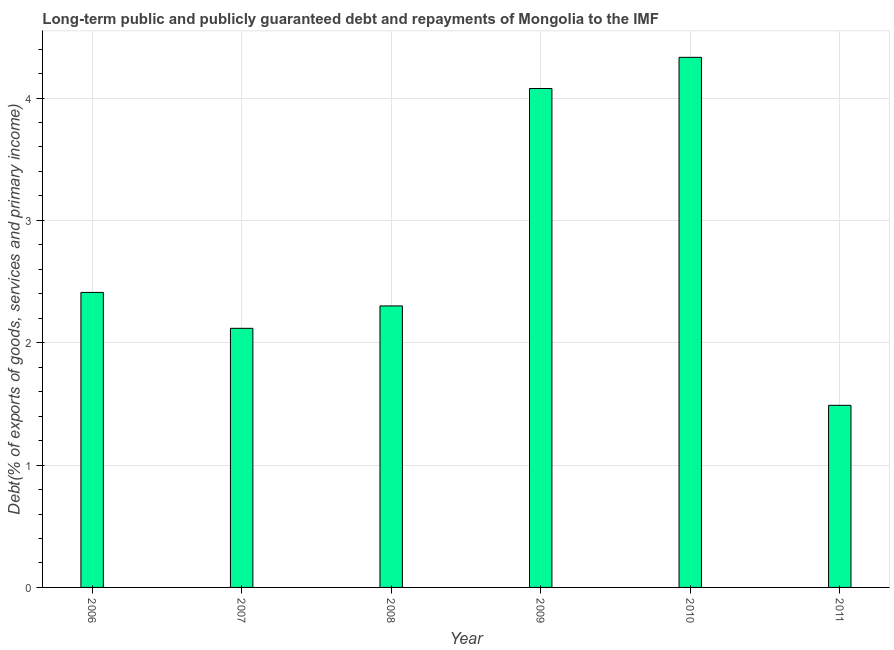Does the graph contain any zero values?
Your response must be concise. No. Does the graph contain grids?
Provide a short and direct response. Yes. What is the title of the graph?
Make the answer very short. Long-term public and publicly guaranteed debt and repayments of Mongolia to the IMF. What is the label or title of the Y-axis?
Provide a succinct answer. Debt(% of exports of goods, services and primary income). What is the debt service in 2011?
Your answer should be very brief. 1.49. Across all years, what is the maximum debt service?
Your response must be concise. 4.33. Across all years, what is the minimum debt service?
Your answer should be compact. 1.49. In which year was the debt service minimum?
Your answer should be very brief. 2011. What is the sum of the debt service?
Provide a short and direct response. 16.73. What is the difference between the debt service in 2009 and 2010?
Give a very brief answer. -0.26. What is the average debt service per year?
Give a very brief answer. 2.79. What is the median debt service?
Give a very brief answer. 2.36. Do a majority of the years between 2009 and 2007 (inclusive) have debt service greater than 3 %?
Your answer should be compact. Yes. What is the ratio of the debt service in 2006 to that in 2008?
Offer a terse response. 1.05. Is the difference between the debt service in 2007 and 2008 greater than the difference between any two years?
Your answer should be very brief. No. What is the difference between the highest and the second highest debt service?
Ensure brevity in your answer.  0.26. What is the difference between the highest and the lowest debt service?
Give a very brief answer. 2.84. Are all the bars in the graph horizontal?
Offer a terse response. No. What is the difference between two consecutive major ticks on the Y-axis?
Make the answer very short. 1. Are the values on the major ticks of Y-axis written in scientific E-notation?
Your answer should be very brief. No. What is the Debt(% of exports of goods, services and primary income) in 2006?
Your answer should be very brief. 2.41. What is the Debt(% of exports of goods, services and primary income) of 2007?
Your response must be concise. 2.12. What is the Debt(% of exports of goods, services and primary income) of 2008?
Offer a terse response. 2.3. What is the Debt(% of exports of goods, services and primary income) in 2009?
Keep it short and to the point. 4.08. What is the Debt(% of exports of goods, services and primary income) in 2010?
Your answer should be compact. 4.33. What is the Debt(% of exports of goods, services and primary income) of 2011?
Your response must be concise. 1.49. What is the difference between the Debt(% of exports of goods, services and primary income) in 2006 and 2007?
Ensure brevity in your answer.  0.29. What is the difference between the Debt(% of exports of goods, services and primary income) in 2006 and 2008?
Keep it short and to the point. 0.11. What is the difference between the Debt(% of exports of goods, services and primary income) in 2006 and 2009?
Ensure brevity in your answer.  -1.67. What is the difference between the Debt(% of exports of goods, services and primary income) in 2006 and 2010?
Offer a terse response. -1.92. What is the difference between the Debt(% of exports of goods, services and primary income) in 2006 and 2011?
Provide a short and direct response. 0.92. What is the difference between the Debt(% of exports of goods, services and primary income) in 2007 and 2008?
Provide a succinct answer. -0.18. What is the difference between the Debt(% of exports of goods, services and primary income) in 2007 and 2009?
Your answer should be compact. -1.96. What is the difference between the Debt(% of exports of goods, services and primary income) in 2007 and 2010?
Keep it short and to the point. -2.22. What is the difference between the Debt(% of exports of goods, services and primary income) in 2007 and 2011?
Your response must be concise. 0.63. What is the difference between the Debt(% of exports of goods, services and primary income) in 2008 and 2009?
Provide a succinct answer. -1.78. What is the difference between the Debt(% of exports of goods, services and primary income) in 2008 and 2010?
Offer a terse response. -2.03. What is the difference between the Debt(% of exports of goods, services and primary income) in 2008 and 2011?
Make the answer very short. 0.81. What is the difference between the Debt(% of exports of goods, services and primary income) in 2009 and 2010?
Give a very brief answer. -0.25. What is the difference between the Debt(% of exports of goods, services and primary income) in 2009 and 2011?
Keep it short and to the point. 2.59. What is the difference between the Debt(% of exports of goods, services and primary income) in 2010 and 2011?
Give a very brief answer. 2.84. What is the ratio of the Debt(% of exports of goods, services and primary income) in 2006 to that in 2007?
Keep it short and to the point. 1.14. What is the ratio of the Debt(% of exports of goods, services and primary income) in 2006 to that in 2008?
Make the answer very short. 1.05. What is the ratio of the Debt(% of exports of goods, services and primary income) in 2006 to that in 2009?
Provide a short and direct response. 0.59. What is the ratio of the Debt(% of exports of goods, services and primary income) in 2006 to that in 2010?
Your answer should be compact. 0.56. What is the ratio of the Debt(% of exports of goods, services and primary income) in 2006 to that in 2011?
Make the answer very short. 1.62. What is the ratio of the Debt(% of exports of goods, services and primary income) in 2007 to that in 2009?
Give a very brief answer. 0.52. What is the ratio of the Debt(% of exports of goods, services and primary income) in 2007 to that in 2010?
Your response must be concise. 0.49. What is the ratio of the Debt(% of exports of goods, services and primary income) in 2007 to that in 2011?
Offer a very short reply. 1.42. What is the ratio of the Debt(% of exports of goods, services and primary income) in 2008 to that in 2009?
Provide a succinct answer. 0.56. What is the ratio of the Debt(% of exports of goods, services and primary income) in 2008 to that in 2010?
Provide a short and direct response. 0.53. What is the ratio of the Debt(% of exports of goods, services and primary income) in 2008 to that in 2011?
Provide a succinct answer. 1.55. What is the ratio of the Debt(% of exports of goods, services and primary income) in 2009 to that in 2010?
Your response must be concise. 0.94. What is the ratio of the Debt(% of exports of goods, services and primary income) in 2009 to that in 2011?
Your answer should be compact. 2.74. What is the ratio of the Debt(% of exports of goods, services and primary income) in 2010 to that in 2011?
Give a very brief answer. 2.91. 